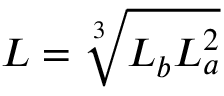Convert formula to latex. <formula><loc_0><loc_0><loc_500><loc_500>L = \sqrt { [ } 3 ] { L _ { b } L _ { a } ^ { 2 } }</formula> 